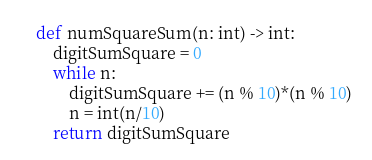<code> <loc_0><loc_0><loc_500><loc_500><_Python_>
def numSquareSum(n: int) -> int:
    digitSumSquare = 0
    while n:
        digitSumSquare += (n % 10)*(n % 10)
        n = int(n/10)
    return digitSumSquare
</code> 